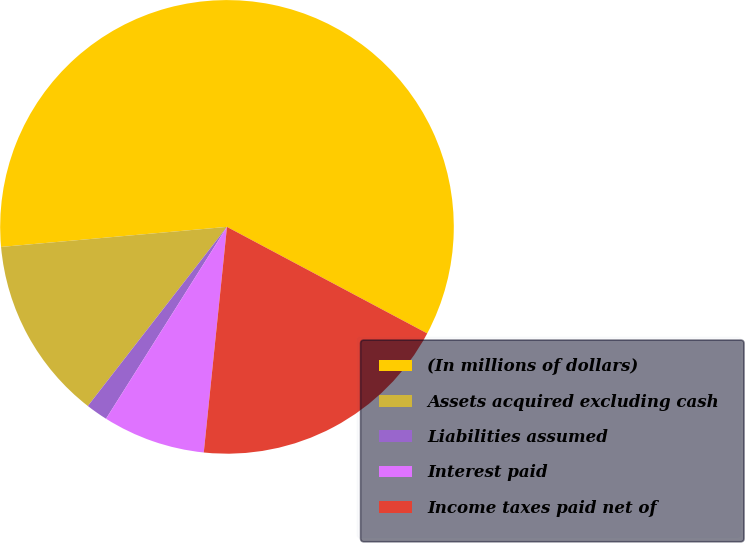Convert chart to OTSL. <chart><loc_0><loc_0><loc_500><loc_500><pie_chart><fcel>(In millions of dollars)<fcel>Assets acquired excluding cash<fcel>Liabilities assumed<fcel>Interest paid<fcel>Income taxes paid net of<nl><fcel>59.19%<fcel>13.08%<fcel>1.56%<fcel>7.32%<fcel>18.85%<nl></chart> 